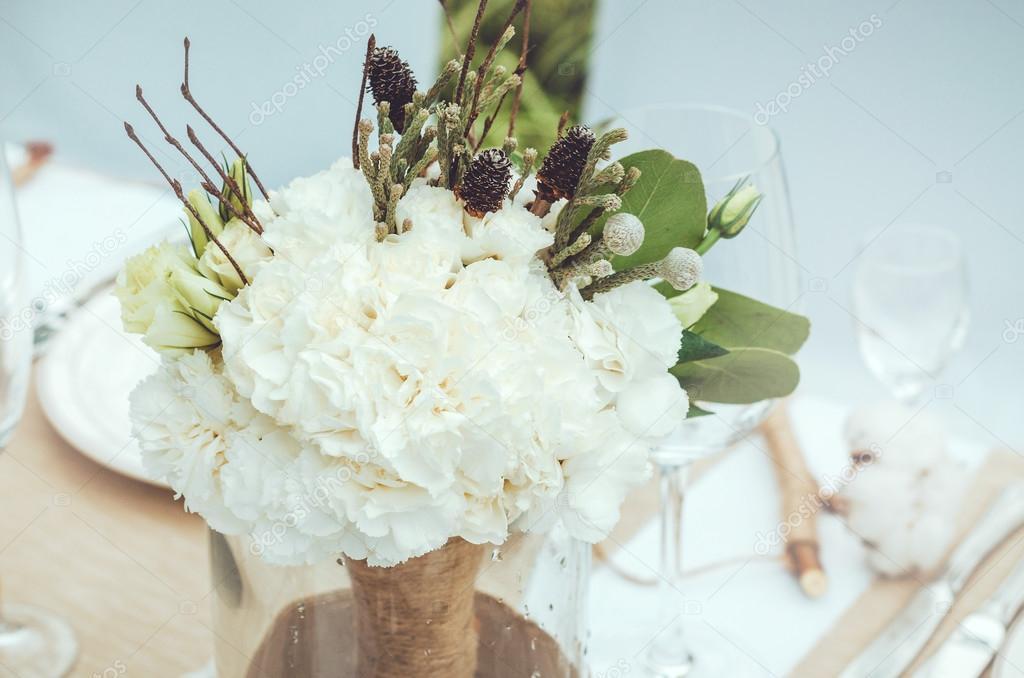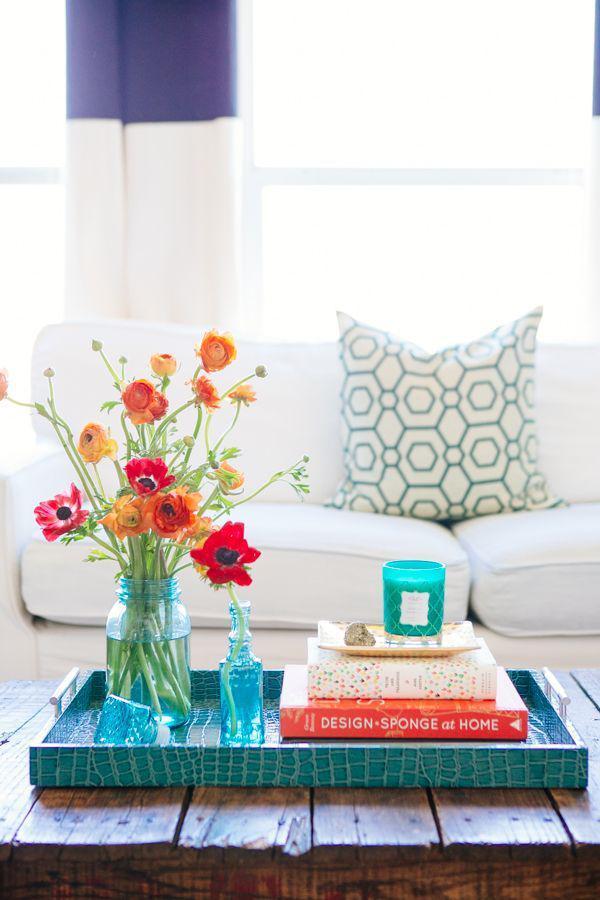The first image is the image on the left, the second image is the image on the right. Considering the images on both sides, is "There are books with the flowers." valid? Answer yes or no. Yes. The first image is the image on the left, the second image is the image on the right. Given the left and right images, does the statement "Each image contains exactly one vase of flowers, and the vase in one image contains multiple flower colors, while the other contains flowers with a single petal color." hold true? Answer yes or no. Yes. 